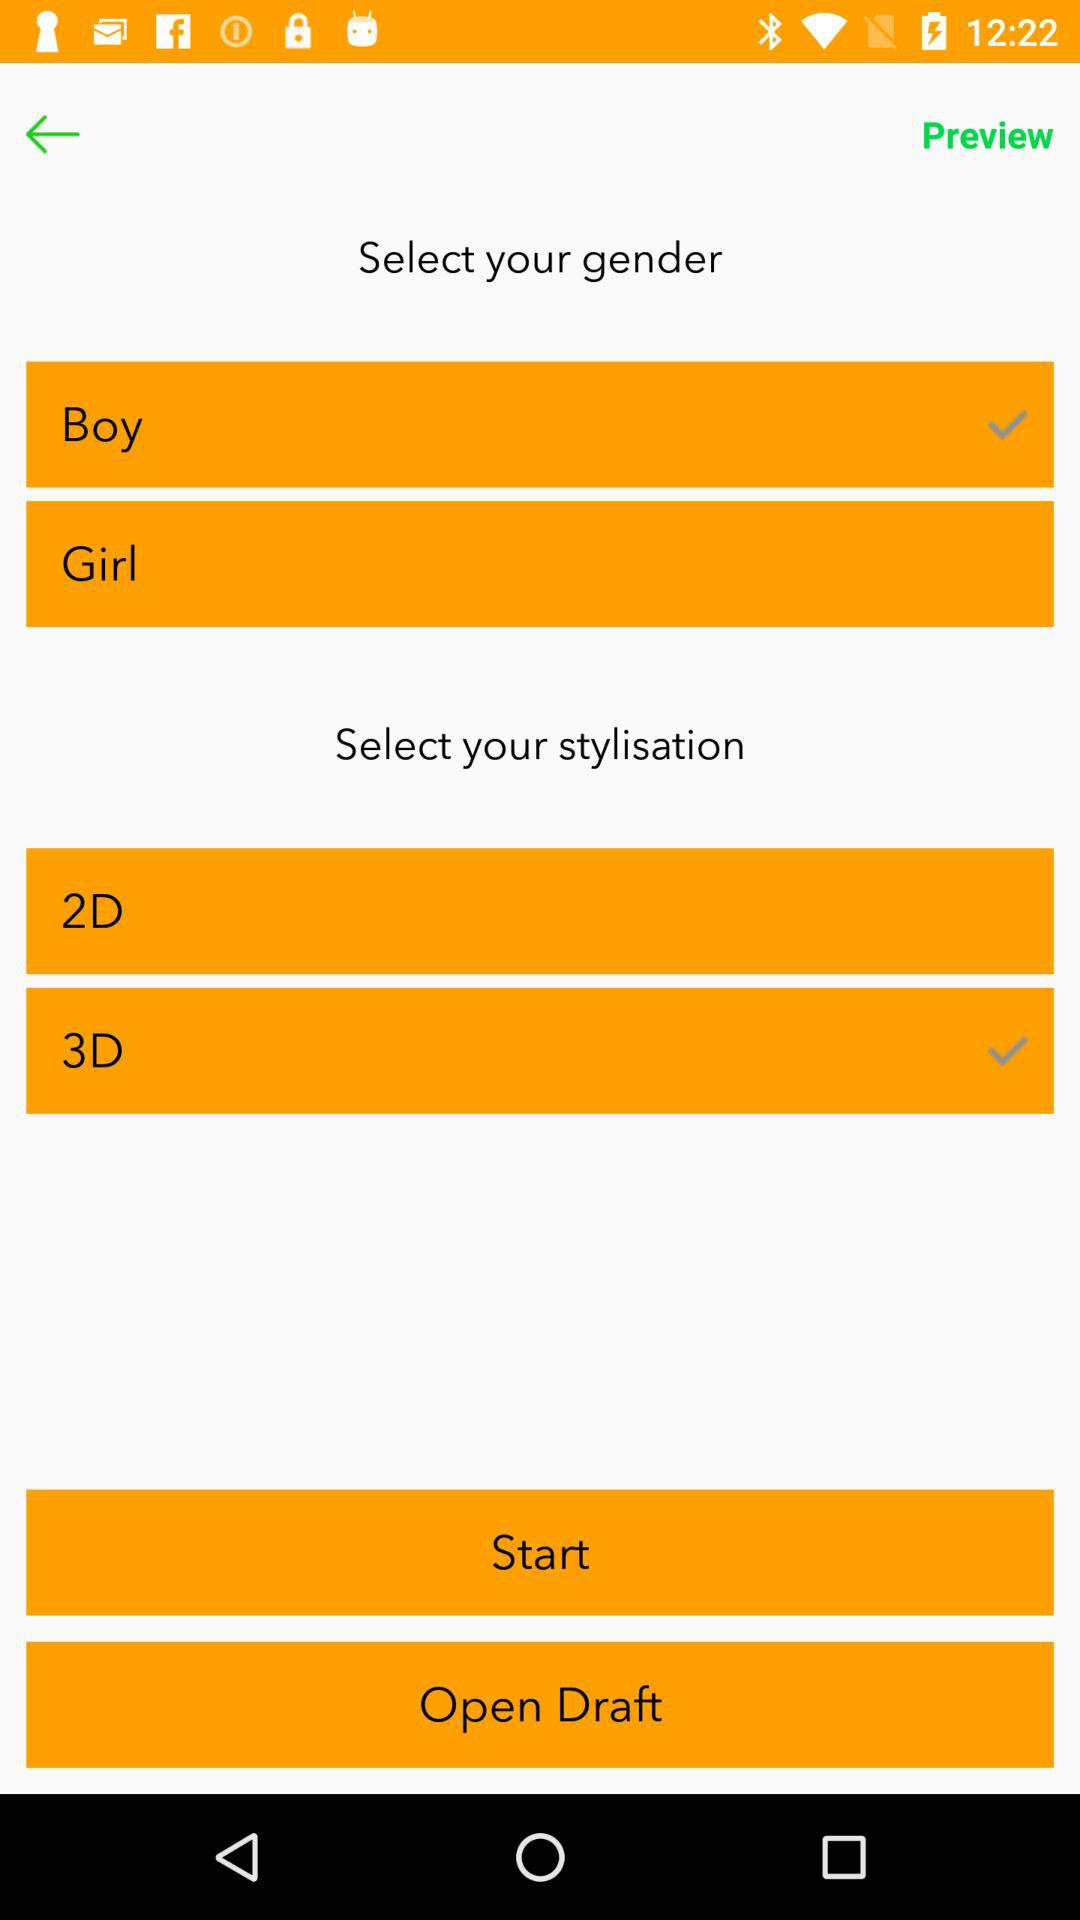What gender is selected?
Answer the question using a single word or phrase. It's a boy. 